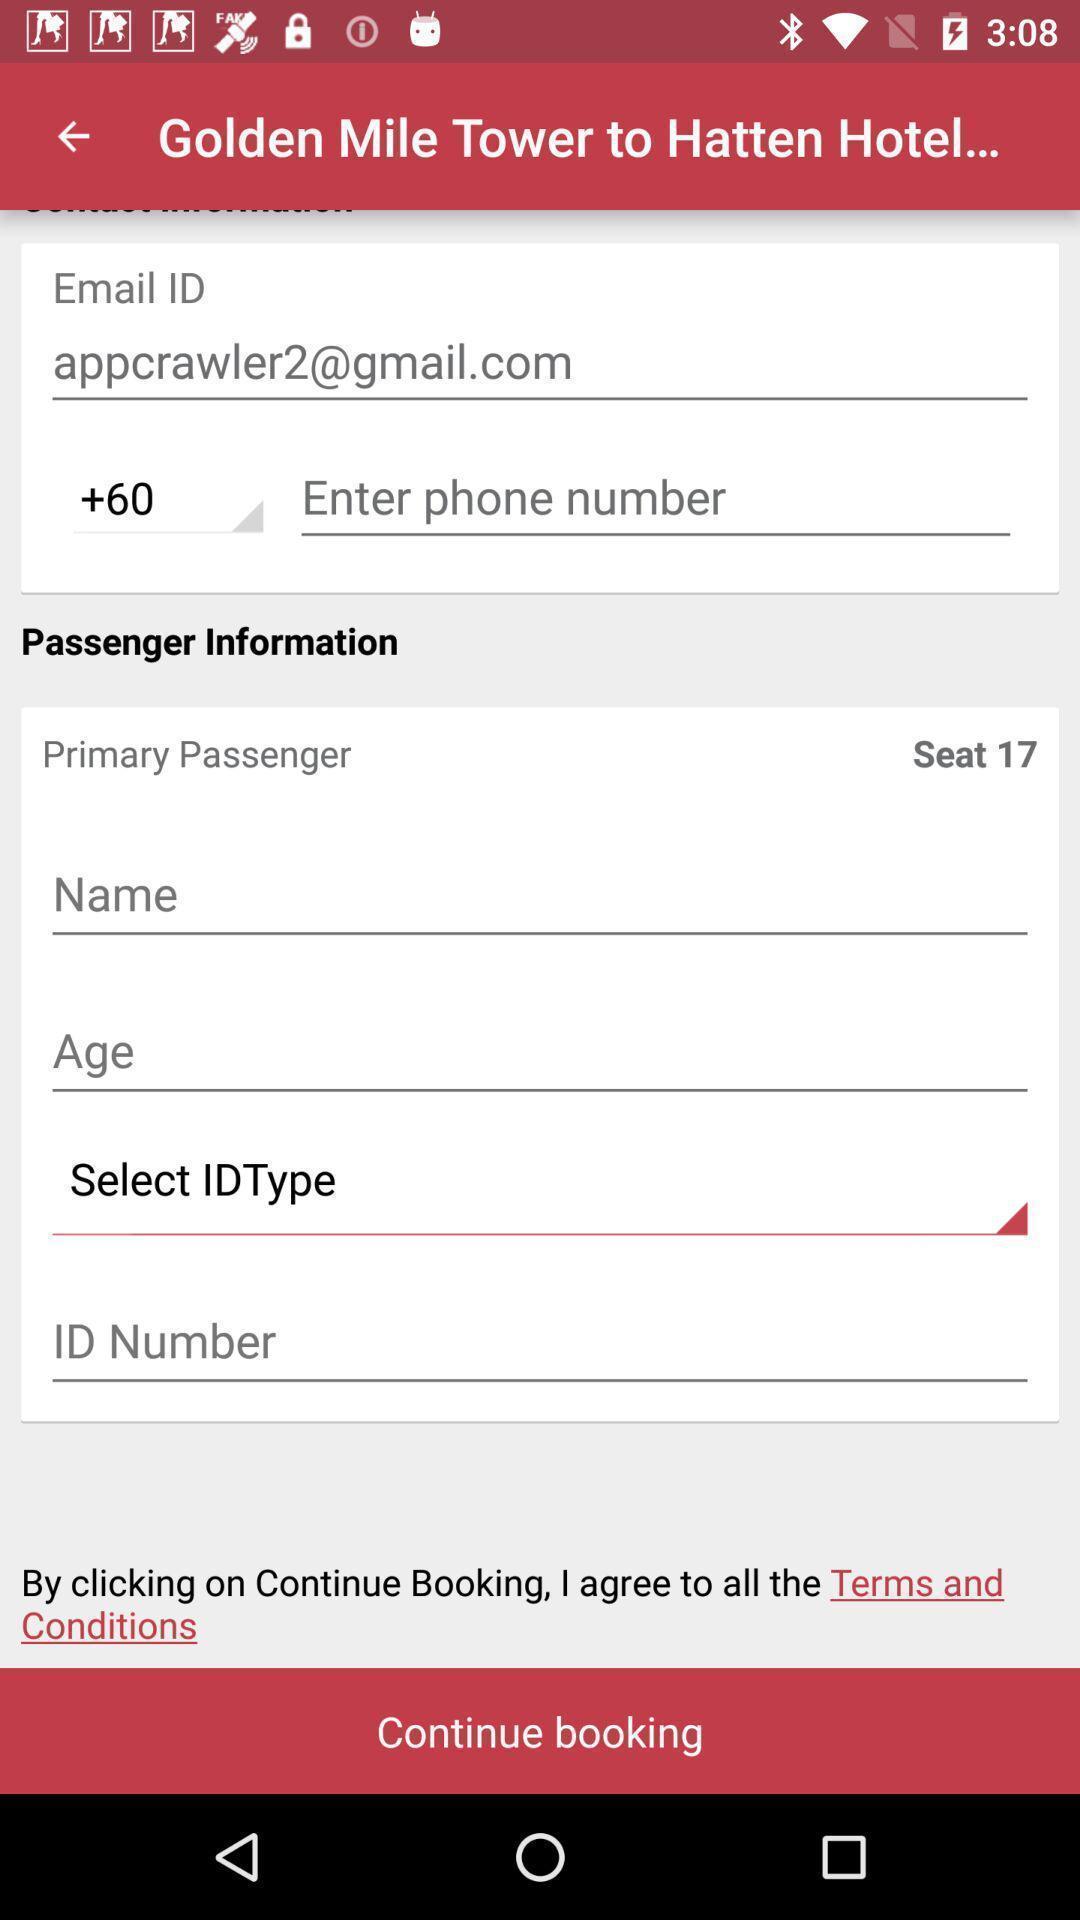Provide a detailed account of this screenshot. Page shows to give your information for booking your seat. 